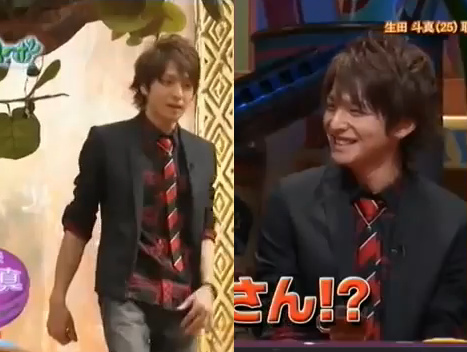What type of clothing is not folded, the shirt or the coat? The shirt is not folded. 